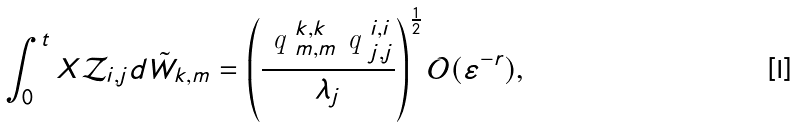<formula> <loc_0><loc_0><loc_500><loc_500>\int _ { 0 } ^ { t } X \mathcal { Z } _ { i , j } d \tilde { W } _ { k , m } = \left ( \frac { \emph { q } _ { m , m } ^ { k , k } \emph { q } _ { j , j } ^ { i , i } } { \lambda _ { j } } \right ) ^ { \frac { 1 } { 2 } } \mathcal { O } ( \varepsilon ^ { - r } ) ,</formula> 